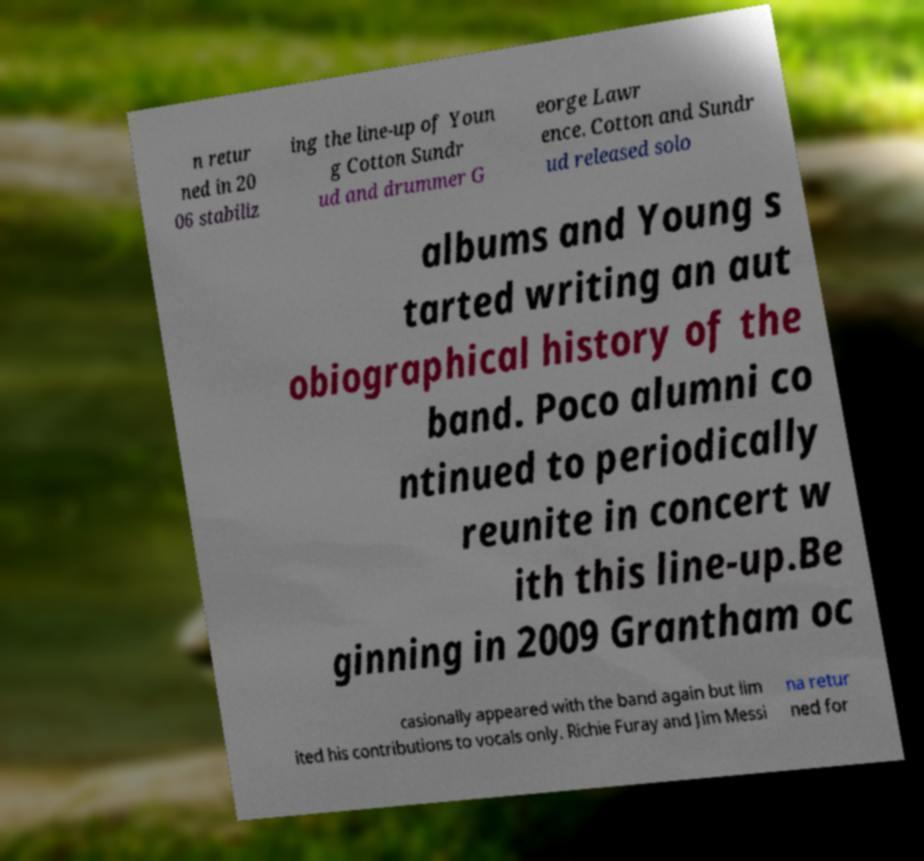Please identify and transcribe the text found in this image. n retur ned in 20 06 stabiliz ing the line-up of Youn g Cotton Sundr ud and drummer G eorge Lawr ence. Cotton and Sundr ud released solo albums and Young s tarted writing an aut obiographical history of the band. Poco alumni co ntinued to periodically reunite in concert w ith this line-up.Be ginning in 2009 Grantham oc casionally appeared with the band again but lim ited his contributions to vocals only. Richie Furay and Jim Messi na retur ned for 